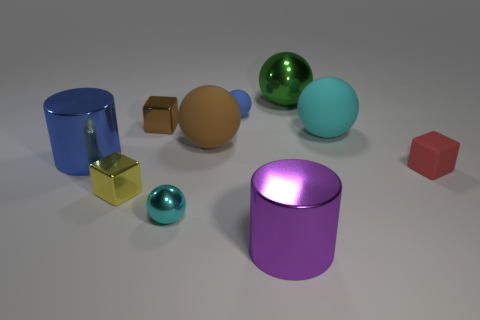Subtract all green balls. How many balls are left? 4 Subtract all big metal balls. How many balls are left? 4 Subtract all yellow balls. Subtract all brown cylinders. How many balls are left? 5 Subtract all blocks. How many objects are left? 7 Subtract all shiny objects. Subtract all big purple things. How many objects are left? 3 Add 8 cyan metallic objects. How many cyan metallic objects are left? 9 Add 8 brown spheres. How many brown spheres exist? 9 Subtract 0 green blocks. How many objects are left? 10 